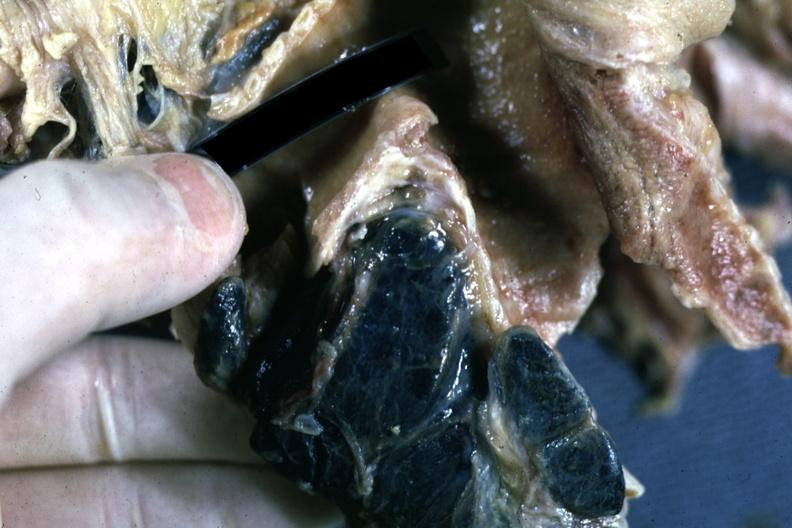how are carinal nodes shown close-up nodes filled with pigment?
Answer the question using a single word or phrase. Black 